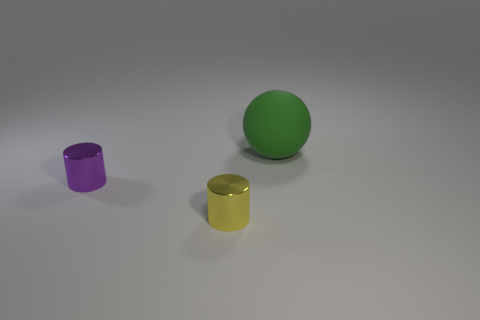Add 3 green objects. How many objects exist? 6 Subtract all spheres. How many objects are left? 2 Subtract all large things. Subtract all small cylinders. How many objects are left? 0 Add 3 metallic things. How many metallic things are left? 5 Add 1 green balls. How many green balls exist? 2 Subtract 0 gray cylinders. How many objects are left? 3 